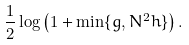Convert formula to latex. <formula><loc_0><loc_0><loc_500><loc_500>\frac { 1 } { 2 } \log \left ( 1 + \min \{ g , N ^ { 2 } h \} \right ) .</formula> 